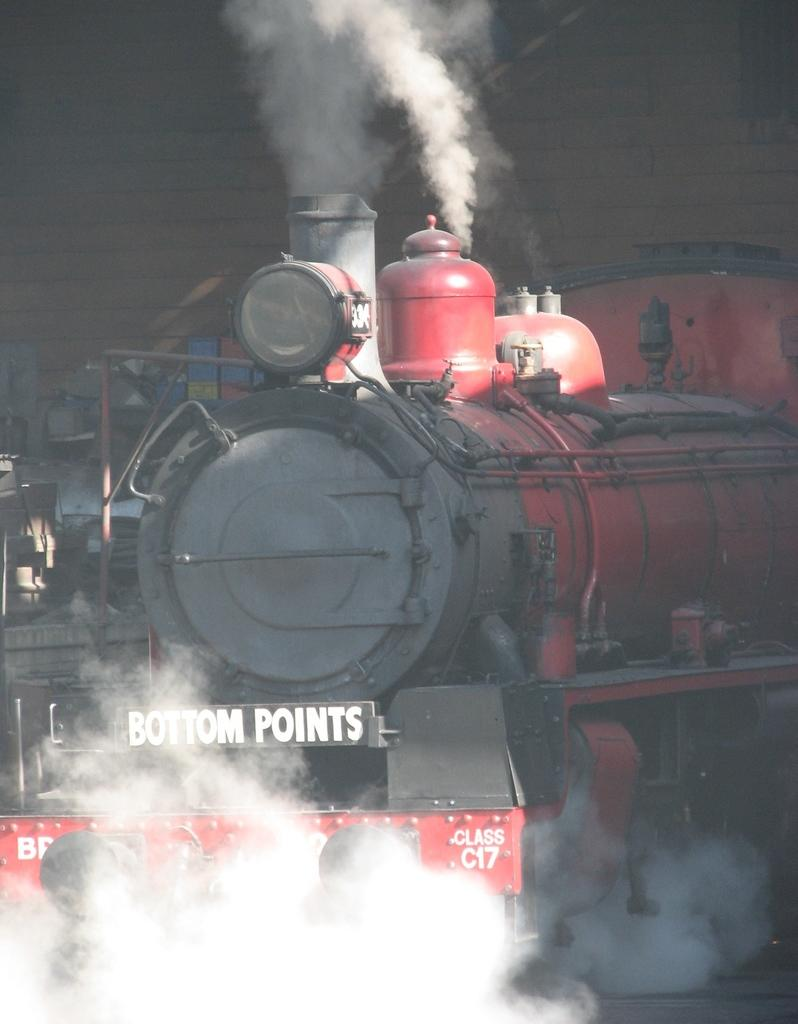What type of vehicle is in the image? There is a steam engine in the image. What else can be seen in the image besides the steam engine? There is text visible in the image, and smoke is present. What is the background of the image? There is a wall in the image. How many babies are crawling on the front of the steam engine in the image? There are no babies present in the image; it only features a steam engine, text, smoke, and a wall. 